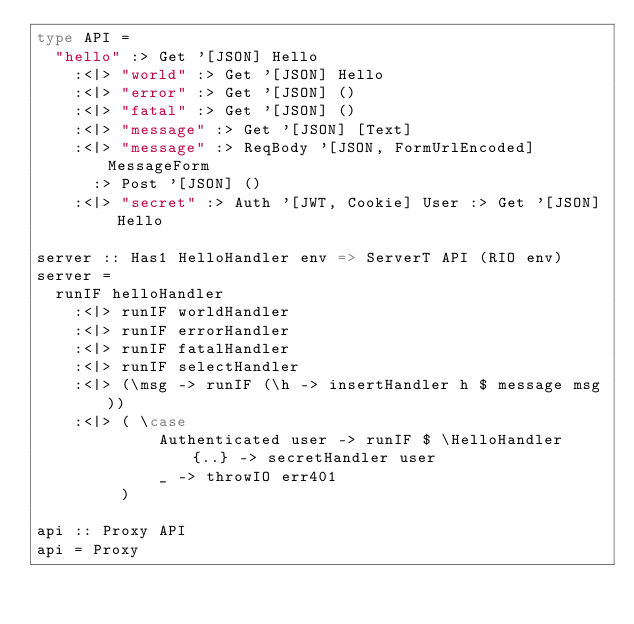Convert code to text. <code><loc_0><loc_0><loc_500><loc_500><_Haskell_>type API =
  "hello" :> Get '[JSON] Hello
    :<|> "world" :> Get '[JSON] Hello
    :<|> "error" :> Get '[JSON] ()
    :<|> "fatal" :> Get '[JSON] ()
    :<|> "message" :> Get '[JSON] [Text]
    :<|> "message" :> ReqBody '[JSON, FormUrlEncoded] MessageForm
      :> Post '[JSON] ()
    :<|> "secret" :> Auth '[JWT, Cookie] User :> Get '[JSON] Hello

server :: Has1 HelloHandler env => ServerT API (RIO env)
server =
  runIF helloHandler
    :<|> runIF worldHandler
    :<|> runIF errorHandler
    :<|> runIF fatalHandler
    :<|> runIF selectHandler
    :<|> (\msg -> runIF (\h -> insertHandler h $ message msg))
    :<|> ( \case
             Authenticated user -> runIF $ \HelloHandler {..} -> secretHandler user
             _ -> throwIO err401
         )

api :: Proxy API
api = Proxy</code> 